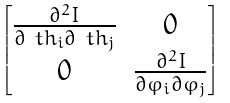<formula> <loc_0><loc_0><loc_500><loc_500>\begin{bmatrix} \frac { \partial ^ { 2 } I } { \partial \ t h _ { i } \partial \ t h _ { j } } & 0 \\ 0 & \frac { \partial ^ { 2 } I } { \partial \varphi _ { i } \partial \varphi _ { j } } \end{bmatrix}</formula> 